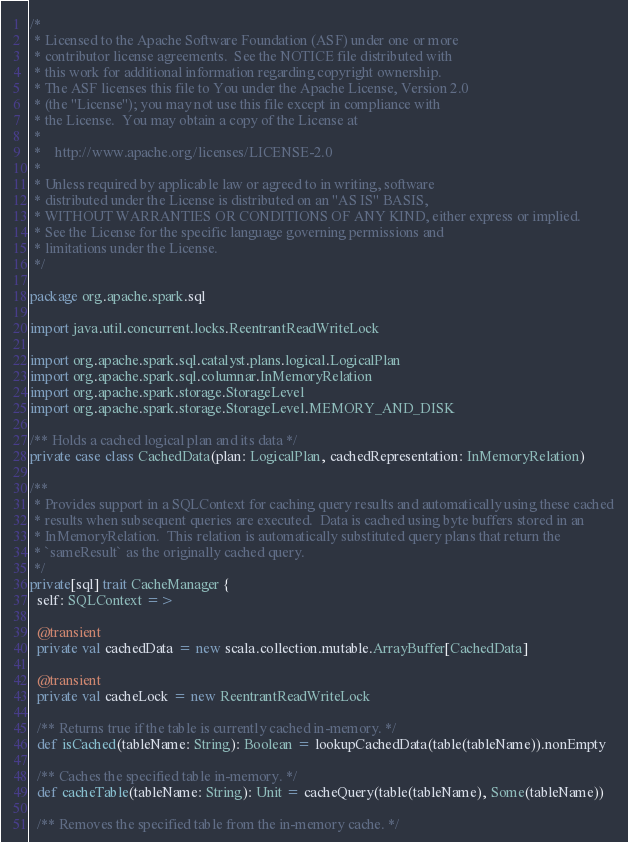<code> <loc_0><loc_0><loc_500><loc_500><_Scala_>/*
 * Licensed to the Apache Software Foundation (ASF) under one or more
 * contributor license agreements.  See the NOTICE file distributed with
 * this work for additional information regarding copyright ownership.
 * The ASF licenses this file to You under the Apache License, Version 2.0
 * (the "License"); you may not use this file except in compliance with
 * the License.  You may obtain a copy of the License at
 *
 *    http://www.apache.org/licenses/LICENSE-2.0
 *
 * Unless required by applicable law or agreed to in writing, software
 * distributed under the License is distributed on an "AS IS" BASIS,
 * WITHOUT WARRANTIES OR CONDITIONS OF ANY KIND, either express or implied.
 * See the License for the specific language governing permissions and
 * limitations under the License.
 */

package org.apache.spark.sql

import java.util.concurrent.locks.ReentrantReadWriteLock

import org.apache.spark.sql.catalyst.plans.logical.LogicalPlan
import org.apache.spark.sql.columnar.InMemoryRelation
import org.apache.spark.storage.StorageLevel
import org.apache.spark.storage.StorageLevel.MEMORY_AND_DISK

/** Holds a cached logical plan and its data */
private case class CachedData(plan: LogicalPlan, cachedRepresentation: InMemoryRelation)

/**
 * Provides support in a SQLContext for caching query results and automatically using these cached
 * results when subsequent queries are executed.  Data is cached using byte buffers stored in an
 * InMemoryRelation.  This relation is automatically substituted query plans that return the
 * `sameResult` as the originally cached query.
 */
private[sql] trait CacheManager {
  self: SQLContext =>

  @transient
  private val cachedData = new scala.collection.mutable.ArrayBuffer[CachedData]

  @transient
  private val cacheLock = new ReentrantReadWriteLock

  /** Returns true if the table is currently cached in-memory. */
  def isCached(tableName: String): Boolean = lookupCachedData(table(tableName)).nonEmpty

  /** Caches the specified table in-memory. */
  def cacheTable(tableName: String): Unit = cacheQuery(table(tableName), Some(tableName))

  /** Removes the specified table from the in-memory cache. */</code> 